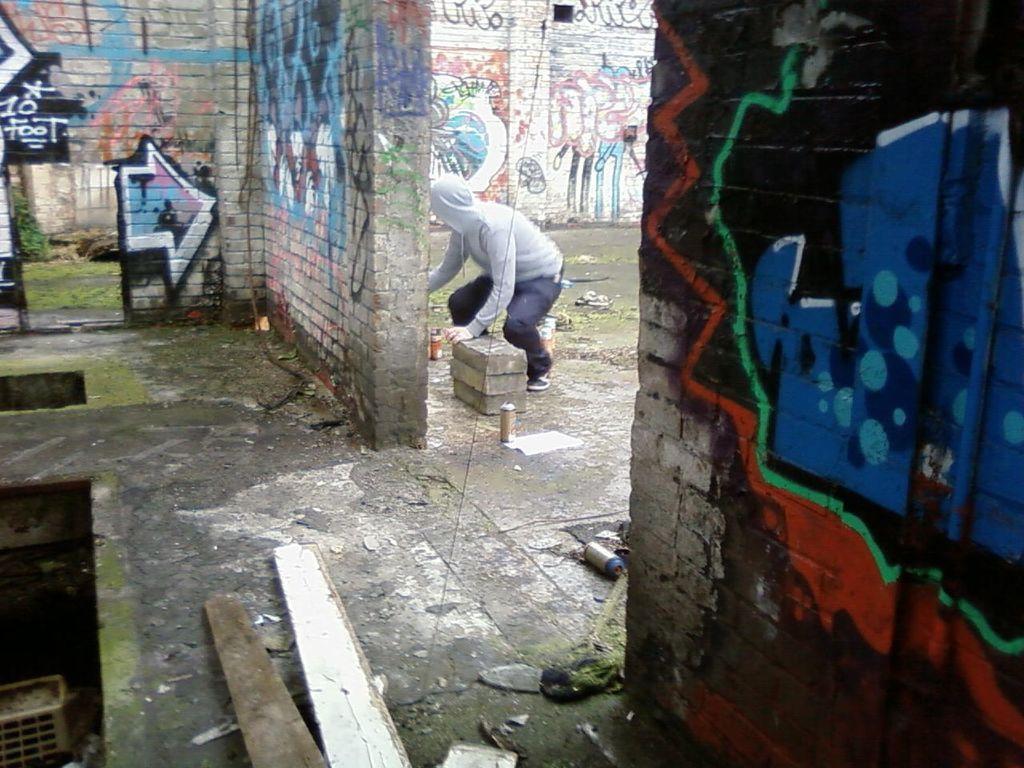How would you summarize this image in a sentence or two? In this image we can see a person. At the bottom there are wooden blocks and we can see bricks. In the background there are walls and we can see graffiti on the walls. 